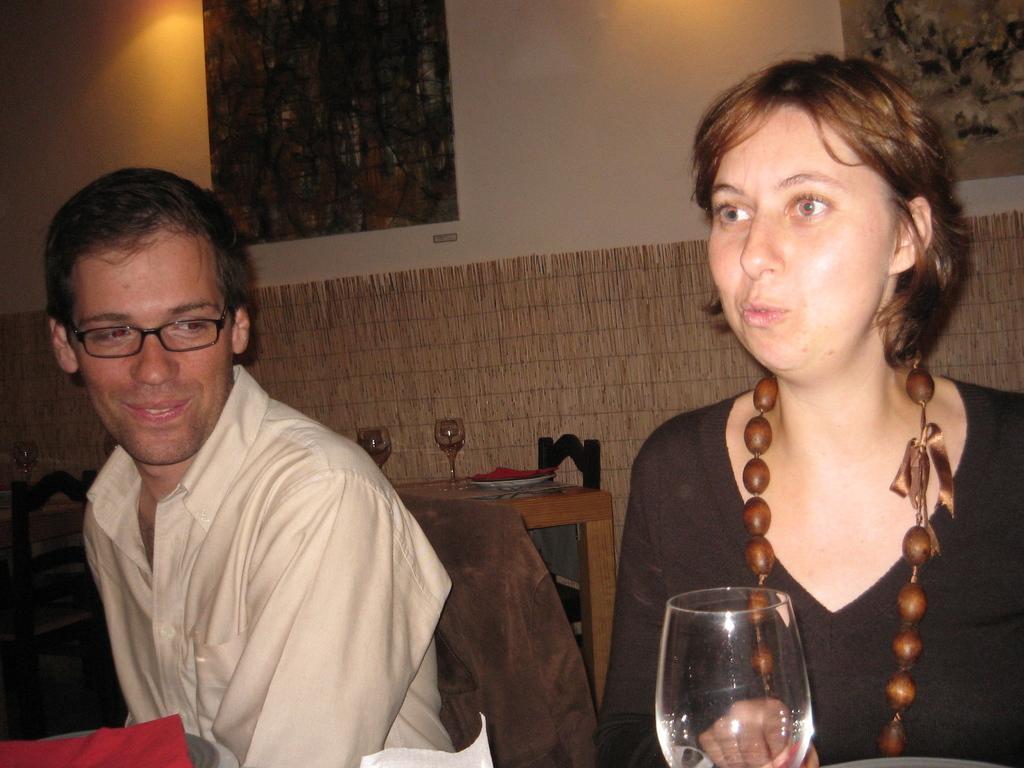Describe this image in one or two sentences. In this image there are two persons, a man and woman. The man is wearing a white shirt and woman is wearing black colored dress. In the background there is a wall with two frames on it. 